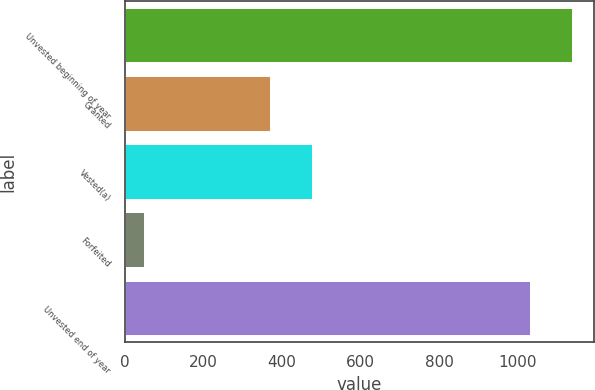<chart> <loc_0><loc_0><loc_500><loc_500><bar_chart><fcel>Unvested beginning of year<fcel>Granted<fcel>Vested(a)<fcel>Forfeited<fcel>Unvested end of year<nl><fcel>1137.3<fcel>369<fcel>476.3<fcel>48<fcel>1030<nl></chart> 